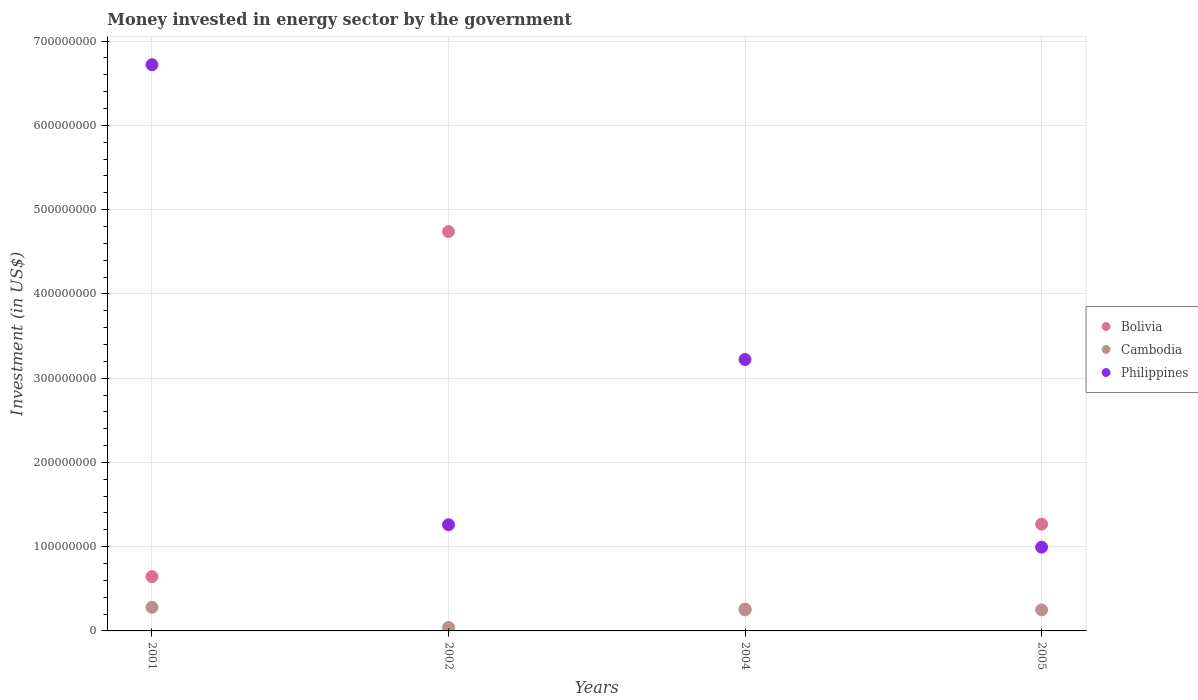How many different coloured dotlines are there?
Your answer should be very brief. 3. What is the money spent in energy sector in Philippines in 2002?
Provide a succinct answer. 1.26e+08. Across all years, what is the maximum money spent in energy sector in Philippines?
Provide a short and direct response. 6.72e+08. Across all years, what is the minimum money spent in energy sector in Cambodia?
Ensure brevity in your answer.  4.10e+06. What is the total money spent in energy sector in Cambodia in the graph?
Ensure brevity in your answer.  8.21e+07. What is the difference between the money spent in energy sector in Bolivia in 2001 and that in 2004?
Your response must be concise. 3.85e+07. What is the difference between the money spent in energy sector in Cambodia in 2004 and the money spent in energy sector in Bolivia in 2005?
Provide a short and direct response. -1.02e+08. What is the average money spent in energy sector in Cambodia per year?
Provide a short and direct response. 2.05e+07. In the year 2002, what is the difference between the money spent in energy sector in Philippines and money spent in energy sector in Bolivia?
Make the answer very short. -3.48e+08. In how many years, is the money spent in energy sector in Bolivia greater than 160000000 US$?
Offer a very short reply. 1. What is the ratio of the money spent in energy sector in Bolivia in 2004 to that in 2005?
Provide a short and direct response. 0.2. Is the money spent in energy sector in Bolivia in 2002 less than that in 2005?
Your answer should be very brief. No. Is the difference between the money spent in energy sector in Philippines in 2002 and 2004 greater than the difference between the money spent in energy sector in Bolivia in 2002 and 2004?
Ensure brevity in your answer.  No. What is the difference between the highest and the second highest money spent in energy sector in Cambodia?
Give a very brief answer. 3.00e+06. What is the difference between the highest and the lowest money spent in energy sector in Bolivia?
Offer a terse response. 4.48e+08. Does the money spent in energy sector in Bolivia monotonically increase over the years?
Your answer should be very brief. No. What is the difference between two consecutive major ticks on the Y-axis?
Offer a very short reply. 1.00e+08. Are the values on the major ticks of Y-axis written in scientific E-notation?
Provide a succinct answer. No. Does the graph contain any zero values?
Ensure brevity in your answer.  No. Does the graph contain grids?
Offer a terse response. Yes. Where does the legend appear in the graph?
Your answer should be compact. Center right. How many legend labels are there?
Provide a short and direct response. 3. How are the legend labels stacked?
Ensure brevity in your answer.  Vertical. What is the title of the graph?
Make the answer very short. Money invested in energy sector by the government. Does "Colombia" appear as one of the legend labels in the graph?
Offer a terse response. No. What is the label or title of the X-axis?
Your answer should be compact. Years. What is the label or title of the Y-axis?
Give a very brief answer. Investment (in US$). What is the Investment (in US$) of Bolivia in 2001?
Make the answer very short. 6.44e+07. What is the Investment (in US$) of Cambodia in 2001?
Offer a very short reply. 2.80e+07. What is the Investment (in US$) of Philippines in 2001?
Provide a succinct answer. 6.72e+08. What is the Investment (in US$) in Bolivia in 2002?
Provide a short and direct response. 4.74e+08. What is the Investment (in US$) of Cambodia in 2002?
Provide a succinct answer. 4.10e+06. What is the Investment (in US$) of Philippines in 2002?
Keep it short and to the point. 1.26e+08. What is the Investment (in US$) of Bolivia in 2004?
Make the answer very short. 2.59e+07. What is the Investment (in US$) of Cambodia in 2004?
Your answer should be very brief. 2.50e+07. What is the Investment (in US$) of Philippines in 2004?
Offer a terse response. 3.22e+08. What is the Investment (in US$) in Bolivia in 2005?
Provide a succinct answer. 1.27e+08. What is the Investment (in US$) in Cambodia in 2005?
Give a very brief answer. 2.50e+07. What is the Investment (in US$) of Philippines in 2005?
Your response must be concise. 9.94e+07. Across all years, what is the maximum Investment (in US$) of Bolivia?
Offer a terse response. 4.74e+08. Across all years, what is the maximum Investment (in US$) of Cambodia?
Your answer should be very brief. 2.80e+07. Across all years, what is the maximum Investment (in US$) in Philippines?
Offer a terse response. 6.72e+08. Across all years, what is the minimum Investment (in US$) of Bolivia?
Keep it short and to the point. 2.59e+07. Across all years, what is the minimum Investment (in US$) in Cambodia?
Your answer should be very brief. 4.10e+06. Across all years, what is the minimum Investment (in US$) in Philippines?
Make the answer very short. 9.94e+07. What is the total Investment (in US$) of Bolivia in the graph?
Provide a short and direct response. 6.91e+08. What is the total Investment (in US$) in Cambodia in the graph?
Ensure brevity in your answer.  8.21e+07. What is the total Investment (in US$) in Philippines in the graph?
Provide a succinct answer. 1.22e+09. What is the difference between the Investment (in US$) of Bolivia in 2001 and that in 2002?
Make the answer very short. -4.10e+08. What is the difference between the Investment (in US$) in Cambodia in 2001 and that in 2002?
Your answer should be very brief. 2.39e+07. What is the difference between the Investment (in US$) in Philippines in 2001 and that in 2002?
Your answer should be compact. 5.46e+08. What is the difference between the Investment (in US$) of Bolivia in 2001 and that in 2004?
Provide a succinct answer. 3.85e+07. What is the difference between the Investment (in US$) in Cambodia in 2001 and that in 2004?
Ensure brevity in your answer.  3.00e+06. What is the difference between the Investment (in US$) of Philippines in 2001 and that in 2004?
Ensure brevity in your answer.  3.50e+08. What is the difference between the Investment (in US$) in Bolivia in 2001 and that in 2005?
Offer a very short reply. -6.23e+07. What is the difference between the Investment (in US$) in Philippines in 2001 and that in 2005?
Provide a short and direct response. 5.73e+08. What is the difference between the Investment (in US$) of Bolivia in 2002 and that in 2004?
Make the answer very short. 4.48e+08. What is the difference between the Investment (in US$) in Cambodia in 2002 and that in 2004?
Your answer should be very brief. -2.09e+07. What is the difference between the Investment (in US$) of Philippines in 2002 and that in 2004?
Offer a very short reply. -1.96e+08. What is the difference between the Investment (in US$) of Bolivia in 2002 and that in 2005?
Your answer should be very brief. 3.47e+08. What is the difference between the Investment (in US$) of Cambodia in 2002 and that in 2005?
Keep it short and to the point. -2.09e+07. What is the difference between the Investment (in US$) in Philippines in 2002 and that in 2005?
Your response must be concise. 2.66e+07. What is the difference between the Investment (in US$) of Bolivia in 2004 and that in 2005?
Provide a short and direct response. -1.01e+08. What is the difference between the Investment (in US$) in Philippines in 2004 and that in 2005?
Your response must be concise. 2.23e+08. What is the difference between the Investment (in US$) of Bolivia in 2001 and the Investment (in US$) of Cambodia in 2002?
Keep it short and to the point. 6.03e+07. What is the difference between the Investment (in US$) in Bolivia in 2001 and the Investment (in US$) in Philippines in 2002?
Your answer should be very brief. -6.16e+07. What is the difference between the Investment (in US$) of Cambodia in 2001 and the Investment (in US$) of Philippines in 2002?
Offer a terse response. -9.80e+07. What is the difference between the Investment (in US$) in Bolivia in 2001 and the Investment (in US$) in Cambodia in 2004?
Your response must be concise. 3.94e+07. What is the difference between the Investment (in US$) in Bolivia in 2001 and the Investment (in US$) in Philippines in 2004?
Offer a terse response. -2.58e+08. What is the difference between the Investment (in US$) in Cambodia in 2001 and the Investment (in US$) in Philippines in 2004?
Provide a short and direct response. -2.94e+08. What is the difference between the Investment (in US$) in Bolivia in 2001 and the Investment (in US$) in Cambodia in 2005?
Provide a succinct answer. 3.94e+07. What is the difference between the Investment (in US$) of Bolivia in 2001 and the Investment (in US$) of Philippines in 2005?
Keep it short and to the point. -3.50e+07. What is the difference between the Investment (in US$) in Cambodia in 2001 and the Investment (in US$) in Philippines in 2005?
Offer a terse response. -7.14e+07. What is the difference between the Investment (in US$) in Bolivia in 2002 and the Investment (in US$) in Cambodia in 2004?
Your answer should be very brief. 4.49e+08. What is the difference between the Investment (in US$) in Bolivia in 2002 and the Investment (in US$) in Philippines in 2004?
Make the answer very short. 1.52e+08. What is the difference between the Investment (in US$) in Cambodia in 2002 and the Investment (in US$) in Philippines in 2004?
Offer a terse response. -3.18e+08. What is the difference between the Investment (in US$) in Bolivia in 2002 and the Investment (in US$) in Cambodia in 2005?
Offer a terse response. 4.49e+08. What is the difference between the Investment (in US$) of Bolivia in 2002 and the Investment (in US$) of Philippines in 2005?
Your response must be concise. 3.75e+08. What is the difference between the Investment (in US$) in Cambodia in 2002 and the Investment (in US$) in Philippines in 2005?
Your response must be concise. -9.53e+07. What is the difference between the Investment (in US$) in Bolivia in 2004 and the Investment (in US$) in Cambodia in 2005?
Keep it short and to the point. 9.00e+05. What is the difference between the Investment (in US$) of Bolivia in 2004 and the Investment (in US$) of Philippines in 2005?
Keep it short and to the point. -7.35e+07. What is the difference between the Investment (in US$) of Cambodia in 2004 and the Investment (in US$) of Philippines in 2005?
Offer a very short reply. -7.44e+07. What is the average Investment (in US$) in Bolivia per year?
Offer a terse response. 1.73e+08. What is the average Investment (in US$) of Cambodia per year?
Make the answer very short. 2.05e+07. What is the average Investment (in US$) in Philippines per year?
Make the answer very short. 3.05e+08. In the year 2001, what is the difference between the Investment (in US$) in Bolivia and Investment (in US$) in Cambodia?
Give a very brief answer. 3.64e+07. In the year 2001, what is the difference between the Investment (in US$) in Bolivia and Investment (in US$) in Philippines?
Ensure brevity in your answer.  -6.08e+08. In the year 2001, what is the difference between the Investment (in US$) of Cambodia and Investment (in US$) of Philippines?
Offer a very short reply. -6.44e+08. In the year 2002, what is the difference between the Investment (in US$) in Bolivia and Investment (in US$) in Cambodia?
Make the answer very short. 4.70e+08. In the year 2002, what is the difference between the Investment (in US$) in Bolivia and Investment (in US$) in Philippines?
Keep it short and to the point. 3.48e+08. In the year 2002, what is the difference between the Investment (in US$) in Cambodia and Investment (in US$) in Philippines?
Provide a succinct answer. -1.22e+08. In the year 2004, what is the difference between the Investment (in US$) of Bolivia and Investment (in US$) of Cambodia?
Keep it short and to the point. 9.00e+05. In the year 2004, what is the difference between the Investment (in US$) of Bolivia and Investment (in US$) of Philippines?
Your response must be concise. -2.96e+08. In the year 2004, what is the difference between the Investment (in US$) of Cambodia and Investment (in US$) of Philippines?
Provide a short and direct response. -2.97e+08. In the year 2005, what is the difference between the Investment (in US$) in Bolivia and Investment (in US$) in Cambodia?
Give a very brief answer. 1.02e+08. In the year 2005, what is the difference between the Investment (in US$) in Bolivia and Investment (in US$) in Philippines?
Provide a short and direct response. 2.73e+07. In the year 2005, what is the difference between the Investment (in US$) in Cambodia and Investment (in US$) in Philippines?
Provide a succinct answer. -7.44e+07. What is the ratio of the Investment (in US$) of Bolivia in 2001 to that in 2002?
Ensure brevity in your answer.  0.14. What is the ratio of the Investment (in US$) of Cambodia in 2001 to that in 2002?
Provide a succinct answer. 6.83. What is the ratio of the Investment (in US$) of Philippines in 2001 to that in 2002?
Make the answer very short. 5.33. What is the ratio of the Investment (in US$) of Bolivia in 2001 to that in 2004?
Offer a terse response. 2.49. What is the ratio of the Investment (in US$) of Cambodia in 2001 to that in 2004?
Your response must be concise. 1.12. What is the ratio of the Investment (in US$) in Philippines in 2001 to that in 2004?
Your answer should be very brief. 2.09. What is the ratio of the Investment (in US$) in Bolivia in 2001 to that in 2005?
Provide a succinct answer. 0.51. What is the ratio of the Investment (in US$) of Cambodia in 2001 to that in 2005?
Offer a very short reply. 1.12. What is the ratio of the Investment (in US$) in Philippines in 2001 to that in 2005?
Make the answer very short. 6.76. What is the ratio of the Investment (in US$) in Bolivia in 2002 to that in 2004?
Offer a very short reply. 18.3. What is the ratio of the Investment (in US$) in Cambodia in 2002 to that in 2004?
Make the answer very short. 0.16. What is the ratio of the Investment (in US$) in Philippines in 2002 to that in 2004?
Your response must be concise. 0.39. What is the ratio of the Investment (in US$) of Bolivia in 2002 to that in 2005?
Your answer should be compact. 3.74. What is the ratio of the Investment (in US$) in Cambodia in 2002 to that in 2005?
Make the answer very short. 0.16. What is the ratio of the Investment (in US$) of Philippines in 2002 to that in 2005?
Ensure brevity in your answer.  1.27. What is the ratio of the Investment (in US$) in Bolivia in 2004 to that in 2005?
Ensure brevity in your answer.  0.2. What is the ratio of the Investment (in US$) of Cambodia in 2004 to that in 2005?
Provide a short and direct response. 1. What is the ratio of the Investment (in US$) in Philippines in 2004 to that in 2005?
Your response must be concise. 3.24. What is the difference between the highest and the second highest Investment (in US$) of Bolivia?
Provide a succinct answer. 3.47e+08. What is the difference between the highest and the second highest Investment (in US$) of Philippines?
Your answer should be very brief. 3.50e+08. What is the difference between the highest and the lowest Investment (in US$) in Bolivia?
Keep it short and to the point. 4.48e+08. What is the difference between the highest and the lowest Investment (in US$) of Cambodia?
Your answer should be compact. 2.39e+07. What is the difference between the highest and the lowest Investment (in US$) of Philippines?
Keep it short and to the point. 5.73e+08. 